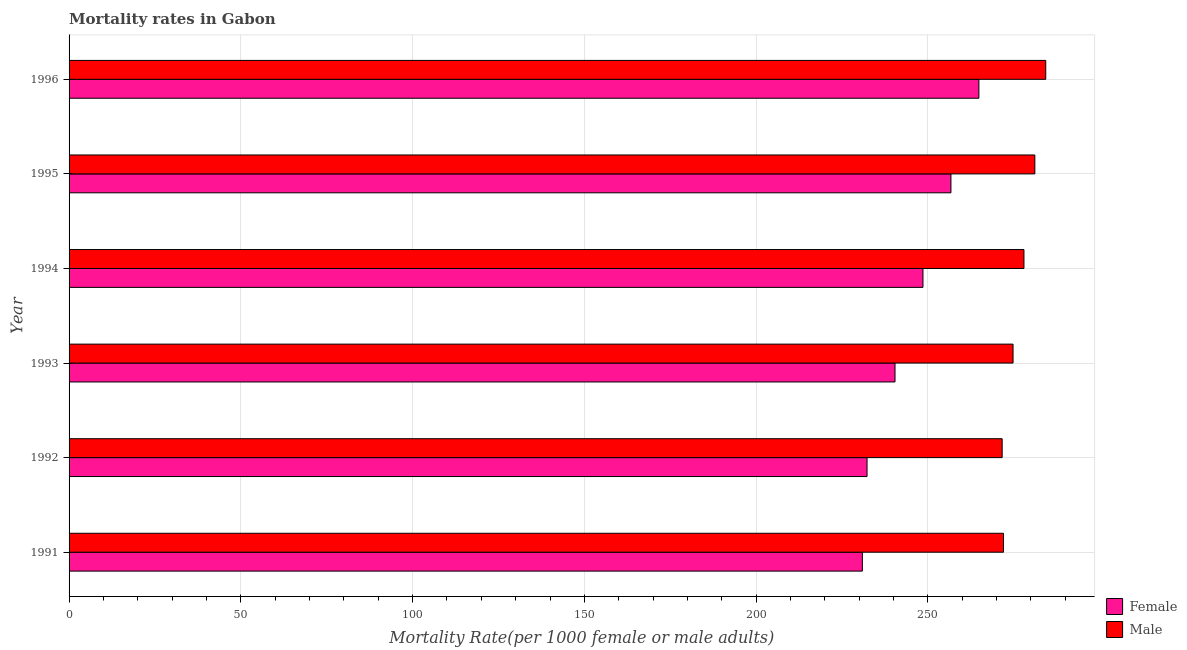How many groups of bars are there?
Offer a very short reply. 6. Are the number of bars on each tick of the Y-axis equal?
Provide a succinct answer. Yes. How many bars are there on the 4th tick from the top?
Your response must be concise. 2. What is the label of the 1st group of bars from the top?
Make the answer very short. 1996. What is the female mortality rate in 1992?
Provide a short and direct response. 232.3. Across all years, what is the maximum female mortality rate?
Keep it short and to the point. 264.86. Across all years, what is the minimum female mortality rate?
Keep it short and to the point. 230.93. In which year was the male mortality rate minimum?
Your response must be concise. 1992. What is the total female mortality rate in the graph?
Your answer should be compact. 1473.82. What is the difference between the male mortality rate in 1994 and that in 1995?
Give a very brief answer. -3.17. What is the difference between the female mortality rate in 1993 and the male mortality rate in 1991?
Your answer should be compact. -31.59. What is the average female mortality rate per year?
Keep it short and to the point. 245.64. In the year 1993, what is the difference between the female mortality rate and male mortality rate?
Keep it short and to the point. -34.36. In how many years, is the male mortality rate greater than 40 ?
Keep it short and to the point. 6. What is the ratio of the female mortality rate in 1994 to that in 1996?
Your response must be concise. 0.94. Is the male mortality rate in 1993 less than that in 1996?
Your answer should be very brief. Yes. What is the difference between the highest and the second highest male mortality rate?
Your answer should be compact. 3.17. What is the difference between the highest and the lowest male mortality rate?
Provide a succinct answer. 12.69. What does the 1st bar from the top in 1994 represents?
Keep it short and to the point. Male. Are all the bars in the graph horizontal?
Your response must be concise. Yes. What is the difference between two consecutive major ticks on the X-axis?
Your response must be concise. 50. Does the graph contain any zero values?
Make the answer very short. No. What is the title of the graph?
Provide a short and direct response. Mortality rates in Gabon. What is the label or title of the X-axis?
Offer a very short reply. Mortality Rate(per 1000 female or male adults). What is the label or title of the Y-axis?
Your answer should be very brief. Year. What is the Mortality Rate(per 1000 female or male adults) of Female in 1991?
Give a very brief answer. 230.93. What is the Mortality Rate(per 1000 female or male adults) in Male in 1991?
Ensure brevity in your answer.  272.02. What is the Mortality Rate(per 1000 female or male adults) in Female in 1992?
Make the answer very short. 232.3. What is the Mortality Rate(per 1000 female or male adults) of Male in 1992?
Your answer should be compact. 271.63. What is the Mortality Rate(per 1000 female or male adults) of Female in 1993?
Give a very brief answer. 240.44. What is the Mortality Rate(per 1000 female or male adults) of Male in 1993?
Provide a succinct answer. 274.8. What is the Mortality Rate(per 1000 female or male adults) of Female in 1994?
Your response must be concise. 248.58. What is the Mortality Rate(per 1000 female or male adults) of Male in 1994?
Offer a very short reply. 277.97. What is the Mortality Rate(per 1000 female or male adults) of Female in 1995?
Your response must be concise. 256.72. What is the Mortality Rate(per 1000 female or male adults) of Male in 1995?
Your answer should be very brief. 281.14. What is the Mortality Rate(per 1000 female or male adults) in Female in 1996?
Give a very brief answer. 264.86. What is the Mortality Rate(per 1000 female or male adults) of Male in 1996?
Offer a terse response. 284.32. Across all years, what is the maximum Mortality Rate(per 1000 female or male adults) in Female?
Ensure brevity in your answer.  264.86. Across all years, what is the maximum Mortality Rate(per 1000 female or male adults) of Male?
Ensure brevity in your answer.  284.32. Across all years, what is the minimum Mortality Rate(per 1000 female or male adults) in Female?
Your response must be concise. 230.93. Across all years, what is the minimum Mortality Rate(per 1000 female or male adults) of Male?
Keep it short and to the point. 271.63. What is the total Mortality Rate(per 1000 female or male adults) in Female in the graph?
Keep it short and to the point. 1473.82. What is the total Mortality Rate(per 1000 female or male adults) of Male in the graph?
Keep it short and to the point. 1661.89. What is the difference between the Mortality Rate(per 1000 female or male adults) in Female in 1991 and that in 1992?
Provide a succinct answer. -1.36. What is the difference between the Mortality Rate(per 1000 female or male adults) of Male in 1991 and that in 1992?
Your answer should be very brief. 0.4. What is the difference between the Mortality Rate(per 1000 female or male adults) of Female in 1991 and that in 1993?
Your response must be concise. -9.5. What is the difference between the Mortality Rate(per 1000 female or male adults) of Male in 1991 and that in 1993?
Keep it short and to the point. -2.77. What is the difference between the Mortality Rate(per 1000 female or male adults) of Female in 1991 and that in 1994?
Your answer should be very brief. -17.64. What is the difference between the Mortality Rate(per 1000 female or male adults) in Male in 1991 and that in 1994?
Your answer should be compact. -5.95. What is the difference between the Mortality Rate(per 1000 female or male adults) of Female in 1991 and that in 1995?
Your response must be concise. -25.79. What is the difference between the Mortality Rate(per 1000 female or male adults) in Male in 1991 and that in 1995?
Provide a short and direct response. -9.12. What is the difference between the Mortality Rate(per 1000 female or male adults) in Female in 1991 and that in 1996?
Ensure brevity in your answer.  -33.92. What is the difference between the Mortality Rate(per 1000 female or male adults) in Male in 1991 and that in 1996?
Keep it short and to the point. -12.29. What is the difference between the Mortality Rate(per 1000 female or male adults) in Female in 1992 and that in 1993?
Provide a short and direct response. -8.14. What is the difference between the Mortality Rate(per 1000 female or male adults) in Male in 1992 and that in 1993?
Make the answer very short. -3.17. What is the difference between the Mortality Rate(per 1000 female or male adults) of Female in 1992 and that in 1994?
Your answer should be very brief. -16.28. What is the difference between the Mortality Rate(per 1000 female or male adults) in Male in 1992 and that in 1994?
Provide a short and direct response. -6.35. What is the difference between the Mortality Rate(per 1000 female or male adults) in Female in 1992 and that in 1995?
Ensure brevity in your answer.  -24.42. What is the difference between the Mortality Rate(per 1000 female or male adults) of Male in 1992 and that in 1995?
Provide a succinct answer. -9.52. What is the difference between the Mortality Rate(per 1000 female or male adults) in Female in 1992 and that in 1996?
Keep it short and to the point. -32.56. What is the difference between the Mortality Rate(per 1000 female or male adults) in Male in 1992 and that in 1996?
Ensure brevity in your answer.  -12.69. What is the difference between the Mortality Rate(per 1000 female or male adults) in Female in 1993 and that in 1994?
Provide a short and direct response. -8.14. What is the difference between the Mortality Rate(per 1000 female or male adults) of Male in 1993 and that in 1994?
Provide a short and direct response. -3.17. What is the difference between the Mortality Rate(per 1000 female or male adults) in Female in 1993 and that in 1995?
Provide a succinct answer. -16.28. What is the difference between the Mortality Rate(per 1000 female or male adults) in Male in 1993 and that in 1995?
Your response must be concise. -6.35. What is the difference between the Mortality Rate(per 1000 female or male adults) in Female in 1993 and that in 1996?
Offer a terse response. -24.42. What is the difference between the Mortality Rate(per 1000 female or male adults) in Male in 1993 and that in 1996?
Provide a short and direct response. -9.52. What is the difference between the Mortality Rate(per 1000 female or male adults) of Female in 1994 and that in 1995?
Offer a very short reply. -8.14. What is the difference between the Mortality Rate(per 1000 female or male adults) in Male in 1994 and that in 1995?
Your answer should be compact. -3.17. What is the difference between the Mortality Rate(per 1000 female or male adults) of Female in 1994 and that in 1996?
Your answer should be very brief. -16.28. What is the difference between the Mortality Rate(per 1000 female or male adults) in Male in 1994 and that in 1996?
Make the answer very short. -6.35. What is the difference between the Mortality Rate(per 1000 female or male adults) of Female in 1995 and that in 1996?
Make the answer very short. -8.14. What is the difference between the Mortality Rate(per 1000 female or male adults) of Male in 1995 and that in 1996?
Offer a very short reply. -3.17. What is the difference between the Mortality Rate(per 1000 female or male adults) in Female in 1991 and the Mortality Rate(per 1000 female or male adults) in Male in 1992?
Your response must be concise. -40.69. What is the difference between the Mortality Rate(per 1000 female or male adults) in Female in 1991 and the Mortality Rate(per 1000 female or male adults) in Male in 1993?
Your answer should be compact. -43.87. What is the difference between the Mortality Rate(per 1000 female or male adults) in Female in 1991 and the Mortality Rate(per 1000 female or male adults) in Male in 1994?
Provide a short and direct response. -47.04. What is the difference between the Mortality Rate(per 1000 female or male adults) in Female in 1991 and the Mortality Rate(per 1000 female or male adults) in Male in 1995?
Give a very brief answer. -50.21. What is the difference between the Mortality Rate(per 1000 female or male adults) of Female in 1991 and the Mortality Rate(per 1000 female or male adults) of Male in 1996?
Your answer should be compact. -53.38. What is the difference between the Mortality Rate(per 1000 female or male adults) of Female in 1992 and the Mortality Rate(per 1000 female or male adults) of Male in 1993?
Offer a very short reply. -42.5. What is the difference between the Mortality Rate(per 1000 female or male adults) in Female in 1992 and the Mortality Rate(per 1000 female or male adults) in Male in 1994?
Offer a terse response. -45.68. What is the difference between the Mortality Rate(per 1000 female or male adults) of Female in 1992 and the Mortality Rate(per 1000 female or male adults) of Male in 1995?
Your answer should be very brief. -48.85. What is the difference between the Mortality Rate(per 1000 female or male adults) in Female in 1992 and the Mortality Rate(per 1000 female or male adults) in Male in 1996?
Give a very brief answer. -52.02. What is the difference between the Mortality Rate(per 1000 female or male adults) of Female in 1993 and the Mortality Rate(per 1000 female or male adults) of Male in 1994?
Your response must be concise. -37.53. What is the difference between the Mortality Rate(per 1000 female or male adults) in Female in 1993 and the Mortality Rate(per 1000 female or male adults) in Male in 1995?
Your response must be concise. -40.71. What is the difference between the Mortality Rate(per 1000 female or male adults) in Female in 1993 and the Mortality Rate(per 1000 female or male adults) in Male in 1996?
Give a very brief answer. -43.88. What is the difference between the Mortality Rate(per 1000 female or male adults) of Female in 1994 and the Mortality Rate(per 1000 female or male adults) of Male in 1995?
Your answer should be very brief. -32.57. What is the difference between the Mortality Rate(per 1000 female or male adults) in Female in 1994 and the Mortality Rate(per 1000 female or male adults) in Male in 1996?
Offer a very short reply. -35.74. What is the difference between the Mortality Rate(per 1000 female or male adults) in Female in 1995 and the Mortality Rate(per 1000 female or male adults) in Male in 1996?
Provide a short and direct response. -27.6. What is the average Mortality Rate(per 1000 female or male adults) in Female per year?
Provide a short and direct response. 245.64. What is the average Mortality Rate(per 1000 female or male adults) of Male per year?
Ensure brevity in your answer.  276.98. In the year 1991, what is the difference between the Mortality Rate(per 1000 female or male adults) of Female and Mortality Rate(per 1000 female or male adults) of Male?
Your answer should be very brief. -41.09. In the year 1992, what is the difference between the Mortality Rate(per 1000 female or male adults) in Female and Mortality Rate(per 1000 female or male adults) in Male?
Your response must be concise. -39.33. In the year 1993, what is the difference between the Mortality Rate(per 1000 female or male adults) in Female and Mortality Rate(per 1000 female or male adults) in Male?
Offer a terse response. -34.36. In the year 1994, what is the difference between the Mortality Rate(per 1000 female or male adults) of Female and Mortality Rate(per 1000 female or male adults) of Male?
Your response must be concise. -29.39. In the year 1995, what is the difference between the Mortality Rate(per 1000 female or male adults) in Female and Mortality Rate(per 1000 female or male adults) in Male?
Provide a succinct answer. -24.43. In the year 1996, what is the difference between the Mortality Rate(per 1000 female or male adults) in Female and Mortality Rate(per 1000 female or male adults) in Male?
Provide a short and direct response. -19.46. What is the ratio of the Mortality Rate(per 1000 female or male adults) in Female in 1991 to that in 1992?
Ensure brevity in your answer.  0.99. What is the ratio of the Mortality Rate(per 1000 female or male adults) of Female in 1991 to that in 1993?
Give a very brief answer. 0.96. What is the ratio of the Mortality Rate(per 1000 female or male adults) in Female in 1991 to that in 1994?
Offer a very short reply. 0.93. What is the ratio of the Mortality Rate(per 1000 female or male adults) in Male in 1991 to that in 1994?
Make the answer very short. 0.98. What is the ratio of the Mortality Rate(per 1000 female or male adults) in Female in 1991 to that in 1995?
Your answer should be compact. 0.9. What is the ratio of the Mortality Rate(per 1000 female or male adults) of Male in 1991 to that in 1995?
Your answer should be compact. 0.97. What is the ratio of the Mortality Rate(per 1000 female or male adults) in Female in 1991 to that in 1996?
Offer a very short reply. 0.87. What is the ratio of the Mortality Rate(per 1000 female or male adults) of Male in 1991 to that in 1996?
Your answer should be very brief. 0.96. What is the ratio of the Mortality Rate(per 1000 female or male adults) in Female in 1992 to that in 1993?
Provide a short and direct response. 0.97. What is the ratio of the Mortality Rate(per 1000 female or male adults) of Female in 1992 to that in 1994?
Keep it short and to the point. 0.93. What is the ratio of the Mortality Rate(per 1000 female or male adults) of Male in 1992 to that in 1994?
Your response must be concise. 0.98. What is the ratio of the Mortality Rate(per 1000 female or male adults) of Female in 1992 to that in 1995?
Provide a succinct answer. 0.9. What is the ratio of the Mortality Rate(per 1000 female or male adults) of Male in 1992 to that in 1995?
Offer a very short reply. 0.97. What is the ratio of the Mortality Rate(per 1000 female or male adults) in Female in 1992 to that in 1996?
Ensure brevity in your answer.  0.88. What is the ratio of the Mortality Rate(per 1000 female or male adults) of Male in 1992 to that in 1996?
Your answer should be compact. 0.96. What is the ratio of the Mortality Rate(per 1000 female or male adults) of Female in 1993 to that in 1994?
Provide a short and direct response. 0.97. What is the ratio of the Mortality Rate(per 1000 female or male adults) of Female in 1993 to that in 1995?
Make the answer very short. 0.94. What is the ratio of the Mortality Rate(per 1000 female or male adults) in Male in 1993 to that in 1995?
Offer a very short reply. 0.98. What is the ratio of the Mortality Rate(per 1000 female or male adults) in Female in 1993 to that in 1996?
Keep it short and to the point. 0.91. What is the ratio of the Mortality Rate(per 1000 female or male adults) of Male in 1993 to that in 1996?
Provide a succinct answer. 0.97. What is the ratio of the Mortality Rate(per 1000 female or male adults) of Female in 1994 to that in 1995?
Your answer should be compact. 0.97. What is the ratio of the Mortality Rate(per 1000 female or male adults) in Male in 1994 to that in 1995?
Ensure brevity in your answer.  0.99. What is the ratio of the Mortality Rate(per 1000 female or male adults) of Female in 1994 to that in 1996?
Ensure brevity in your answer.  0.94. What is the ratio of the Mortality Rate(per 1000 female or male adults) of Male in 1994 to that in 1996?
Provide a succinct answer. 0.98. What is the ratio of the Mortality Rate(per 1000 female or male adults) in Female in 1995 to that in 1996?
Provide a short and direct response. 0.97. What is the ratio of the Mortality Rate(per 1000 female or male adults) of Male in 1995 to that in 1996?
Offer a very short reply. 0.99. What is the difference between the highest and the second highest Mortality Rate(per 1000 female or male adults) of Female?
Ensure brevity in your answer.  8.14. What is the difference between the highest and the second highest Mortality Rate(per 1000 female or male adults) in Male?
Provide a short and direct response. 3.17. What is the difference between the highest and the lowest Mortality Rate(per 1000 female or male adults) of Female?
Ensure brevity in your answer.  33.92. What is the difference between the highest and the lowest Mortality Rate(per 1000 female or male adults) in Male?
Your answer should be compact. 12.69. 